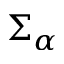Convert formula to latex. <formula><loc_0><loc_0><loc_500><loc_500>\Sigma _ { \alpha }</formula> 